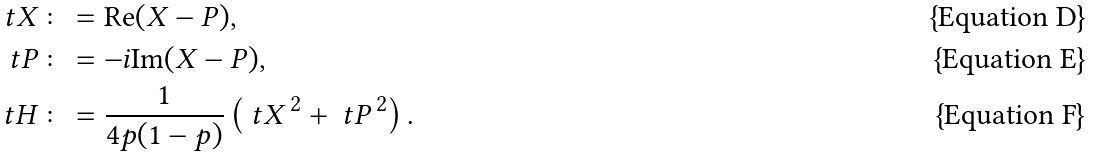<formula> <loc_0><loc_0><loc_500><loc_500>\ t X \colon & = \text {Re} ( X - P ) , \\ \ t P \colon & = - i \text {Im} ( X - P ) , \\ \ t H \colon & = \frac { 1 } { 4 p ( 1 - p ) } \left ( \ t X ^ { \, 2 } + \ t P ^ { \, 2 } \right ) .</formula> 